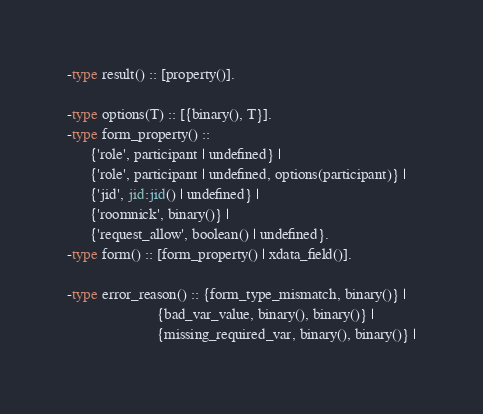<code> <loc_0><loc_0><loc_500><loc_500><_Erlang_>-type result() :: [property()].

-type options(T) :: [{binary(), T}].
-type form_property() ::
      {'role', participant | undefined} |
      {'role', participant | undefined, options(participant)} |
      {'jid', jid:jid() | undefined} |
      {'roomnick', binary()} |
      {'request_allow', boolean() | undefined}.
-type form() :: [form_property() | xdata_field()].

-type error_reason() :: {form_type_mismatch, binary()} |
                        {bad_var_value, binary(), binary()} |
                        {missing_required_var, binary(), binary()} |</code> 